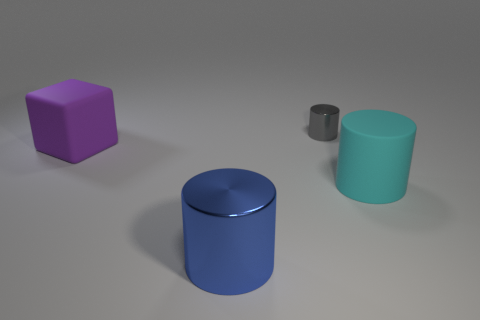Add 4 big cyan metal cubes. How many objects exist? 8 Subtract 1 cyan cylinders. How many objects are left? 3 Subtract all cylinders. How many objects are left? 1 Subtract 1 cubes. How many cubes are left? 0 Subtract all gray cylinders. Subtract all blue balls. How many cylinders are left? 2 Subtract all green balls. How many blue cylinders are left? 1 Subtract all large cylinders. Subtract all cyan cylinders. How many objects are left? 1 Add 2 large blocks. How many large blocks are left? 3 Add 4 tiny green shiny objects. How many tiny green shiny objects exist? 4 Subtract all cyan cylinders. How many cylinders are left? 2 